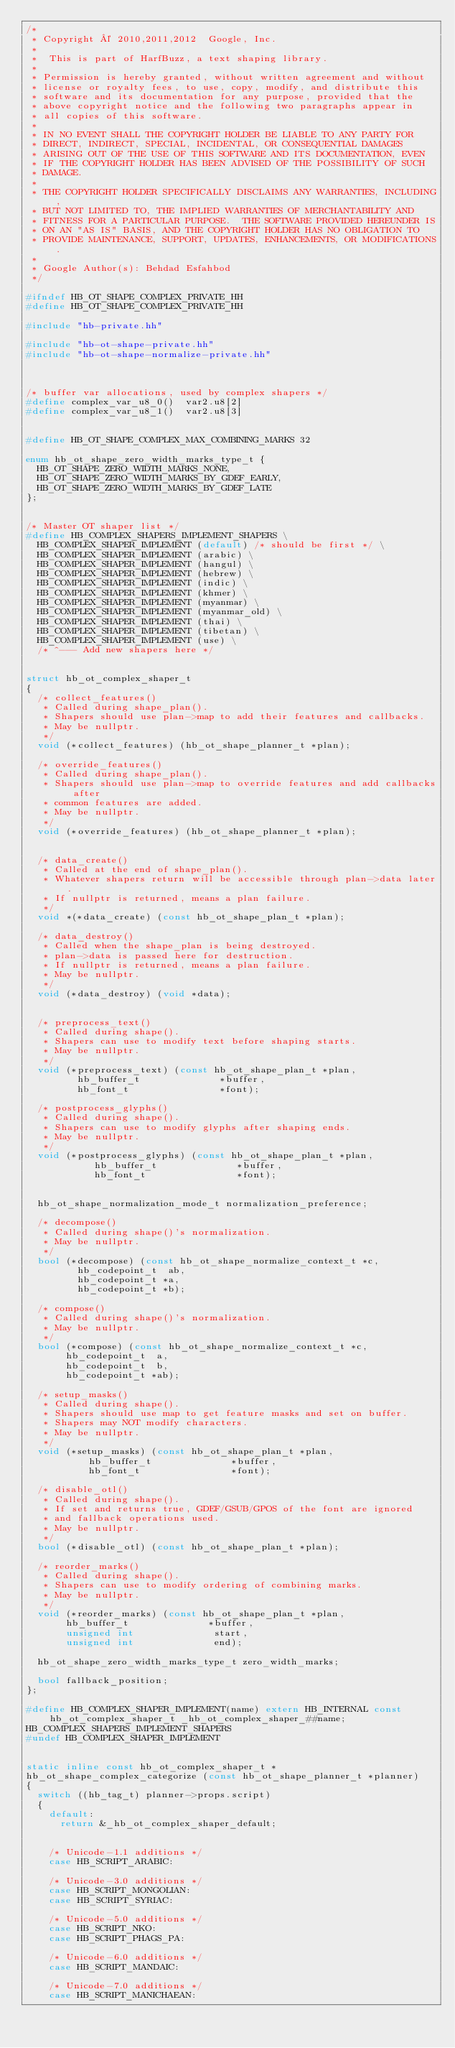Convert code to text. <code><loc_0><loc_0><loc_500><loc_500><_C++_>/*
 * Copyright © 2010,2011,2012  Google, Inc.
 *
 *  This is part of HarfBuzz, a text shaping library.
 *
 * Permission is hereby granted, without written agreement and without
 * license or royalty fees, to use, copy, modify, and distribute this
 * software and its documentation for any purpose, provided that the
 * above copyright notice and the following two paragraphs appear in
 * all copies of this software.
 *
 * IN NO EVENT SHALL THE COPYRIGHT HOLDER BE LIABLE TO ANY PARTY FOR
 * DIRECT, INDIRECT, SPECIAL, INCIDENTAL, OR CONSEQUENTIAL DAMAGES
 * ARISING OUT OF THE USE OF THIS SOFTWARE AND ITS DOCUMENTATION, EVEN
 * IF THE COPYRIGHT HOLDER HAS BEEN ADVISED OF THE POSSIBILITY OF SUCH
 * DAMAGE.
 *
 * THE COPYRIGHT HOLDER SPECIFICALLY DISCLAIMS ANY WARRANTIES, INCLUDING,
 * BUT NOT LIMITED TO, THE IMPLIED WARRANTIES OF MERCHANTABILITY AND
 * FITNESS FOR A PARTICULAR PURPOSE.  THE SOFTWARE PROVIDED HEREUNDER IS
 * ON AN "AS IS" BASIS, AND THE COPYRIGHT HOLDER HAS NO OBLIGATION TO
 * PROVIDE MAINTENANCE, SUPPORT, UPDATES, ENHANCEMENTS, OR MODIFICATIONS.
 *
 * Google Author(s): Behdad Esfahbod
 */

#ifndef HB_OT_SHAPE_COMPLEX_PRIVATE_HH
#define HB_OT_SHAPE_COMPLEX_PRIVATE_HH

#include "hb-private.hh"

#include "hb-ot-shape-private.hh"
#include "hb-ot-shape-normalize-private.hh"



/* buffer var allocations, used by complex shapers */
#define complex_var_u8_0()	var2.u8[2]
#define complex_var_u8_1()	var2.u8[3]


#define HB_OT_SHAPE_COMPLEX_MAX_COMBINING_MARKS 32

enum hb_ot_shape_zero_width_marks_type_t {
  HB_OT_SHAPE_ZERO_WIDTH_MARKS_NONE,
  HB_OT_SHAPE_ZERO_WIDTH_MARKS_BY_GDEF_EARLY,
  HB_OT_SHAPE_ZERO_WIDTH_MARKS_BY_GDEF_LATE
};


/* Master OT shaper list */
#define HB_COMPLEX_SHAPERS_IMPLEMENT_SHAPERS \
  HB_COMPLEX_SHAPER_IMPLEMENT (default) /* should be first */ \
  HB_COMPLEX_SHAPER_IMPLEMENT (arabic) \
  HB_COMPLEX_SHAPER_IMPLEMENT (hangul) \
  HB_COMPLEX_SHAPER_IMPLEMENT (hebrew) \
  HB_COMPLEX_SHAPER_IMPLEMENT (indic) \
  HB_COMPLEX_SHAPER_IMPLEMENT (khmer) \
  HB_COMPLEX_SHAPER_IMPLEMENT (myanmar) \
  HB_COMPLEX_SHAPER_IMPLEMENT (myanmar_old) \
  HB_COMPLEX_SHAPER_IMPLEMENT (thai) \
  HB_COMPLEX_SHAPER_IMPLEMENT (tibetan) \
  HB_COMPLEX_SHAPER_IMPLEMENT (use) \
  /* ^--- Add new shapers here */


struct hb_ot_complex_shaper_t
{
  /* collect_features()
   * Called during shape_plan().
   * Shapers should use plan->map to add their features and callbacks.
   * May be nullptr.
   */
  void (*collect_features) (hb_ot_shape_planner_t *plan);

  /* override_features()
   * Called during shape_plan().
   * Shapers should use plan->map to override features and add callbacks after
   * common features are added.
   * May be nullptr.
   */
  void (*override_features) (hb_ot_shape_planner_t *plan);


  /* data_create()
   * Called at the end of shape_plan().
   * Whatever shapers return will be accessible through plan->data later.
   * If nullptr is returned, means a plan failure.
   */
  void *(*data_create) (const hb_ot_shape_plan_t *plan);

  /* data_destroy()
   * Called when the shape_plan is being destroyed.
   * plan->data is passed here for destruction.
   * If nullptr is returned, means a plan failure.
   * May be nullptr.
   */
  void (*data_destroy) (void *data);


  /* preprocess_text()
   * Called during shape().
   * Shapers can use to modify text before shaping starts.
   * May be nullptr.
   */
  void (*preprocess_text) (const hb_ot_shape_plan_t *plan,
			   hb_buffer_t              *buffer,
			   hb_font_t                *font);

  /* postprocess_glyphs()
   * Called during shape().
   * Shapers can use to modify glyphs after shaping ends.
   * May be nullptr.
   */
  void (*postprocess_glyphs) (const hb_ot_shape_plan_t *plan,
			      hb_buffer_t              *buffer,
			      hb_font_t                *font);


  hb_ot_shape_normalization_mode_t normalization_preference;

  /* decompose()
   * Called during shape()'s normalization.
   * May be nullptr.
   */
  bool (*decompose) (const hb_ot_shape_normalize_context_t *c,
		     hb_codepoint_t  ab,
		     hb_codepoint_t *a,
		     hb_codepoint_t *b);

  /* compose()
   * Called during shape()'s normalization.
   * May be nullptr.
   */
  bool (*compose) (const hb_ot_shape_normalize_context_t *c,
		   hb_codepoint_t  a,
		   hb_codepoint_t  b,
		   hb_codepoint_t *ab);

  /* setup_masks()
   * Called during shape().
   * Shapers should use map to get feature masks and set on buffer.
   * Shapers may NOT modify characters.
   * May be nullptr.
   */
  void (*setup_masks) (const hb_ot_shape_plan_t *plan,
		       hb_buffer_t              *buffer,
		       hb_font_t                *font);

  /* disable_otl()
   * Called during shape().
   * If set and returns true, GDEF/GSUB/GPOS of the font are ignored
   * and fallback operations used.
   * May be nullptr.
   */
  bool (*disable_otl) (const hb_ot_shape_plan_t *plan);

  /* reorder_marks()
   * Called during shape().
   * Shapers can use to modify ordering of combining marks.
   * May be nullptr.
   */
  void (*reorder_marks) (const hb_ot_shape_plan_t *plan,
			 hb_buffer_t              *buffer,
			 unsigned int              start,
			 unsigned int              end);

  hb_ot_shape_zero_width_marks_type_t zero_width_marks;

  bool fallback_position;
};

#define HB_COMPLEX_SHAPER_IMPLEMENT(name) extern HB_INTERNAL const hb_ot_complex_shaper_t _hb_ot_complex_shaper_##name;
HB_COMPLEX_SHAPERS_IMPLEMENT_SHAPERS
#undef HB_COMPLEX_SHAPER_IMPLEMENT


static inline const hb_ot_complex_shaper_t *
hb_ot_shape_complex_categorize (const hb_ot_shape_planner_t *planner)
{
  switch ((hb_tag_t) planner->props.script)
  {
    default:
      return &_hb_ot_complex_shaper_default;


    /* Unicode-1.1 additions */
    case HB_SCRIPT_ARABIC:

    /* Unicode-3.0 additions */
    case HB_SCRIPT_MONGOLIAN:
    case HB_SCRIPT_SYRIAC:

    /* Unicode-5.0 additions */
    case HB_SCRIPT_NKO:
    case HB_SCRIPT_PHAGS_PA:

    /* Unicode-6.0 additions */
    case HB_SCRIPT_MANDAIC:

    /* Unicode-7.0 additions */
    case HB_SCRIPT_MANICHAEAN:</code> 